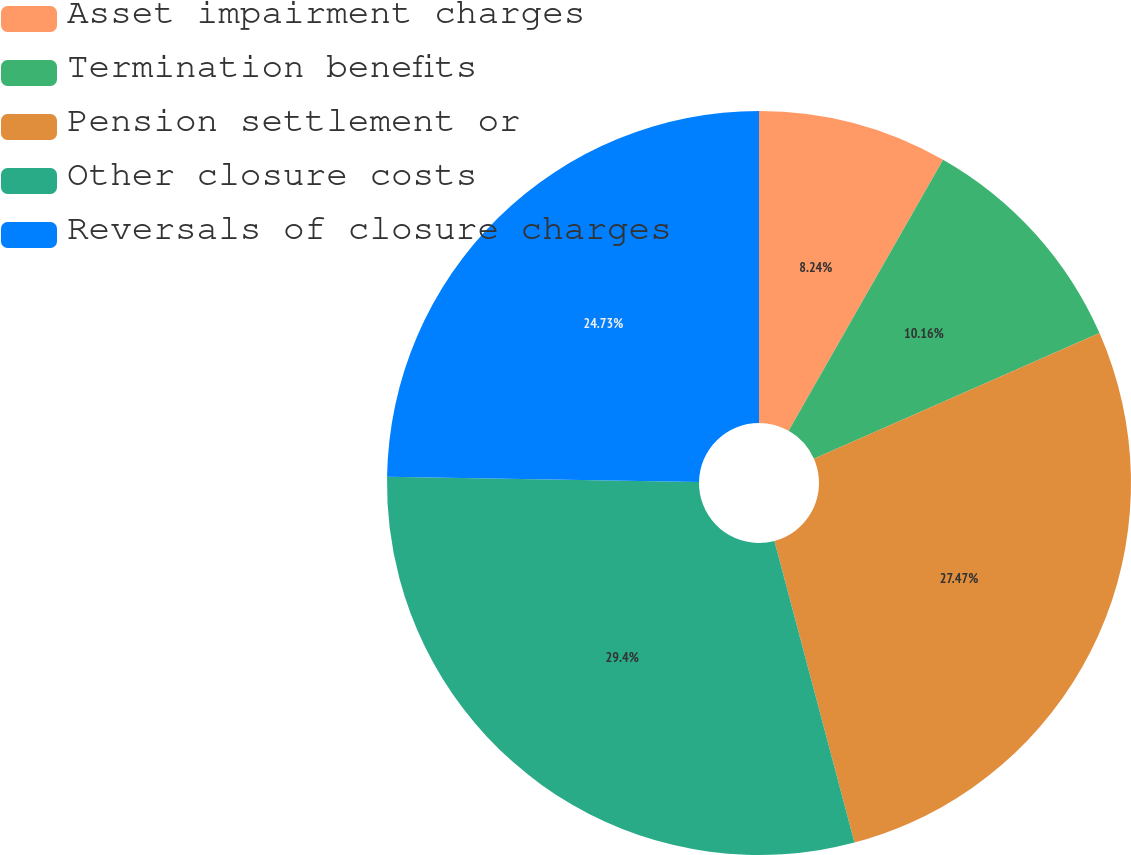Convert chart. <chart><loc_0><loc_0><loc_500><loc_500><pie_chart><fcel>Asset impairment charges<fcel>Termination benefits<fcel>Pension settlement or<fcel>Other closure costs<fcel>Reversals of closure charges<nl><fcel>8.24%<fcel>10.16%<fcel>27.47%<fcel>29.4%<fcel>24.73%<nl></chart> 